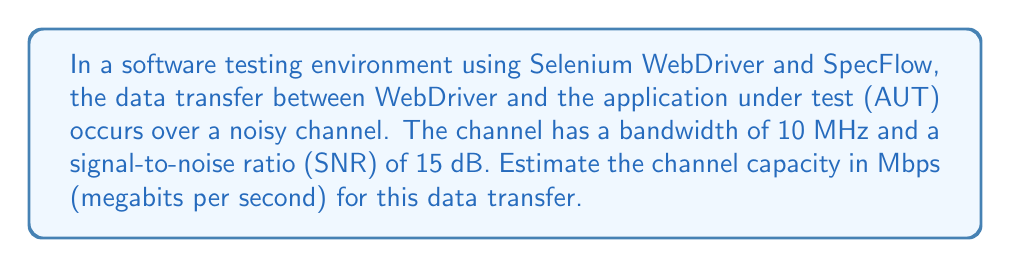Teach me how to tackle this problem. To estimate the channel capacity, we'll use the Shannon-Hartley theorem, which is fundamental in information theory. This theorem is particularly relevant for a project manager overseeing the integration of Selenium WebDriver and SpecFlow, as it helps in understanding the theoretical limits of data transfer in the testing environment.

The Shannon-Hartley theorem is given by:

$$ C = B \log_2(1 + SNR) $$

Where:
$C$ = Channel capacity (bits per second)
$B$ = Bandwidth (Hz)
$SNR$ = Signal-to-Noise Ratio (linear scale)

Given:
$B = 10$ MHz = $10 \times 10^6$ Hz
$SNR = 15$ dB

Step 1: Convert SNR from dB to linear scale
$SNR_{linear} = 10^{\frac{SNR_{dB}}{10}} = 10^{\frac{15}{10}} = 31.6228$

Step 2: Apply the Shannon-Hartley theorem
$$ C = (10 \times 10^6) \log_2(1 + 31.6228) $$

Step 3: Calculate the logarithm
$\log_2(1 + 31.6228) = 5.0224$

Step 4: Multiply the bandwidth by the logarithm result
$C = (10 \times 10^6) \times 5.0224 = 50.224 \times 10^6$ bits per second

Step 5: Convert bits per second to megabits per second
$50.224 \times 10^6$ bps = $50.224$ Mbps

Therefore, the estimated channel capacity for the data transfer between WebDriver and the application under test is approximately 50.224 Mbps.
Answer: 50.224 Mbps 